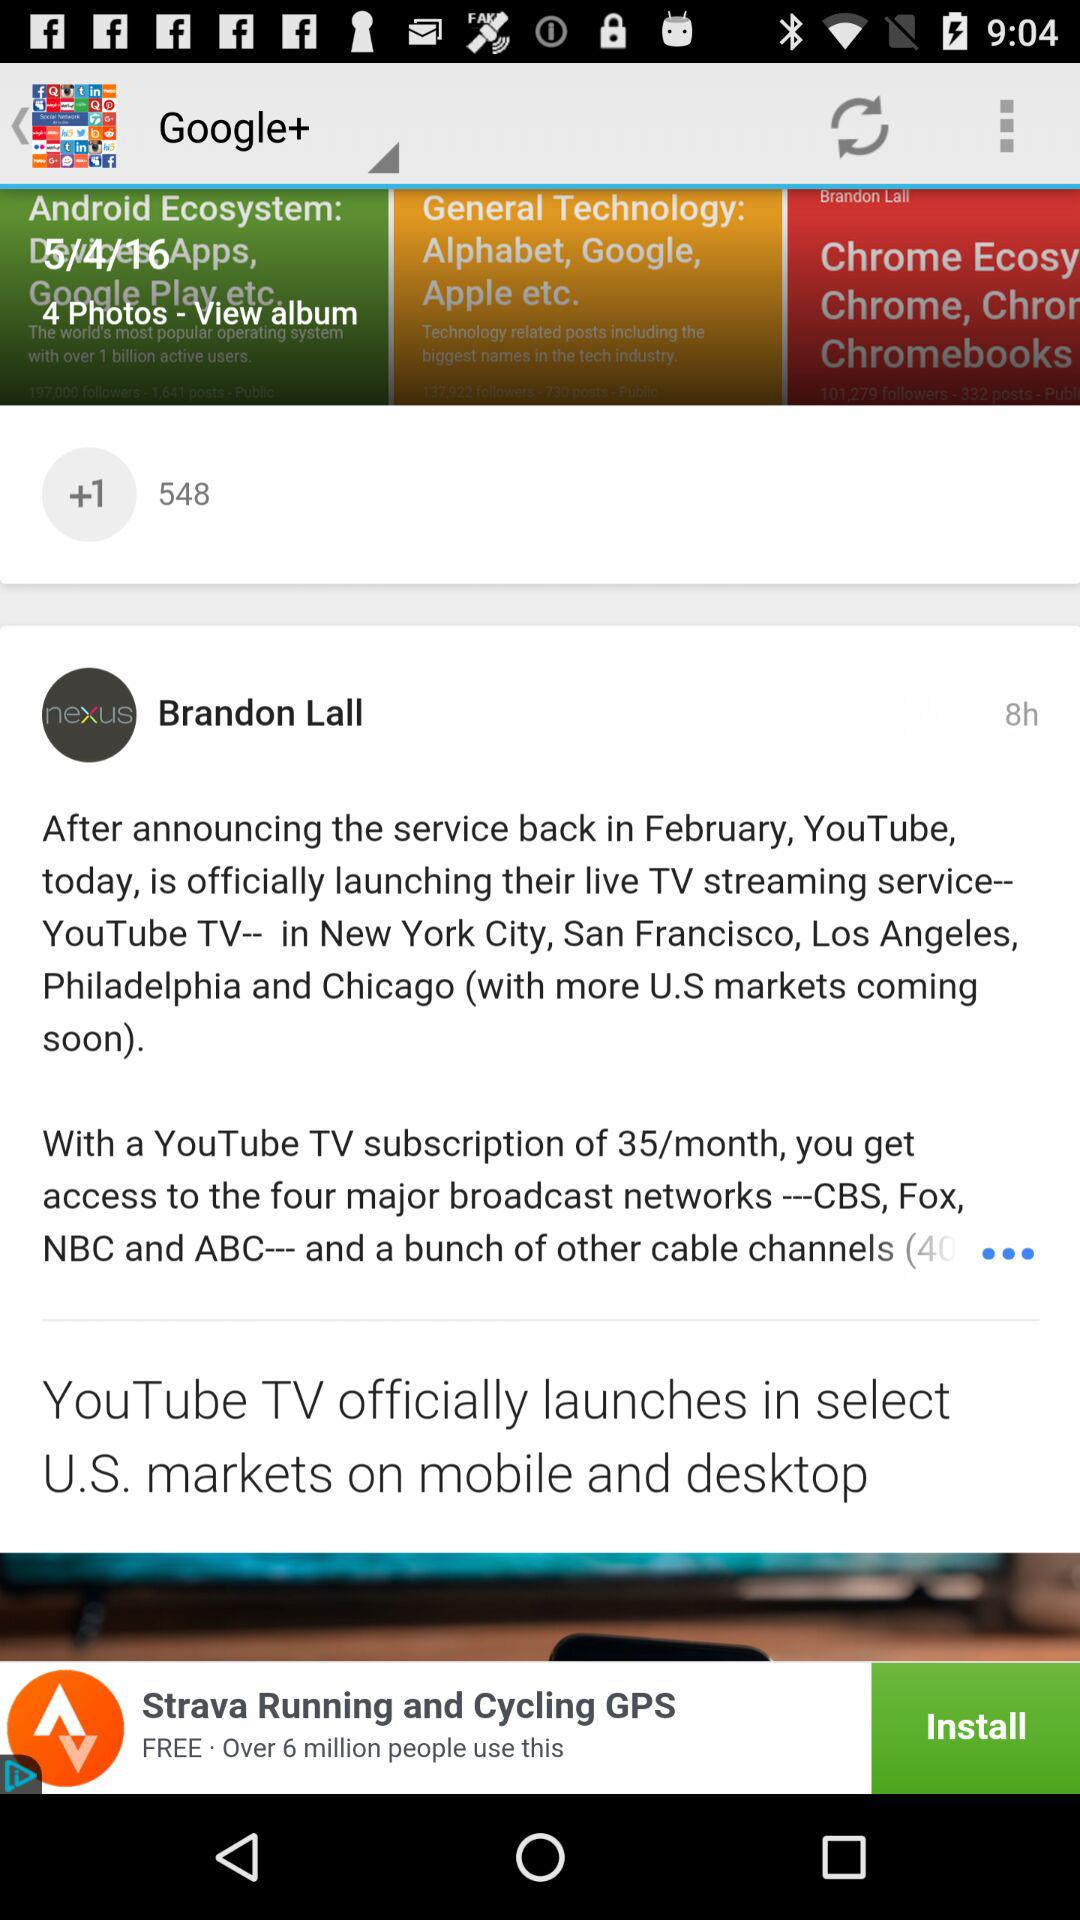How many hours ago was the article posted? The article was posted 8 hours ago. 